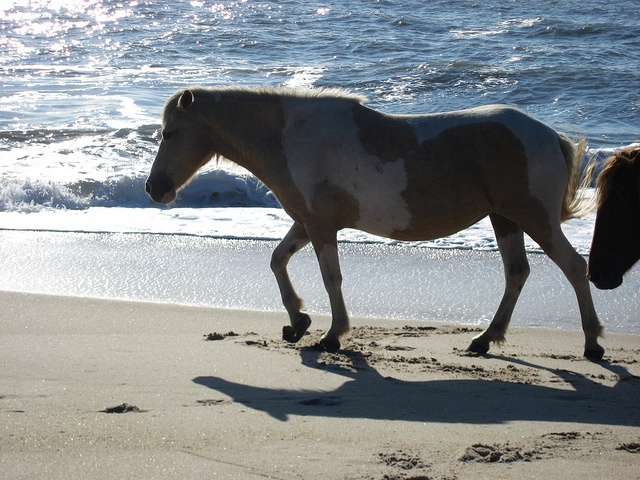Describe the objects in this image and their specific colors. I can see horse in white, black, gray, and darkgray tones and horse in white, black, darkgray, maroon, and gray tones in this image. 